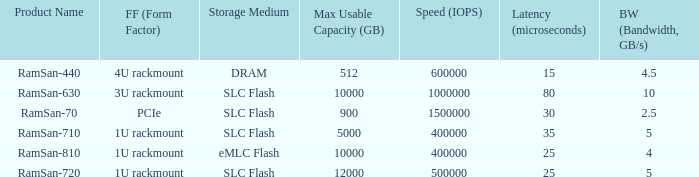What is the shape distortion for the range frequency of 10? 3U rackmount. 